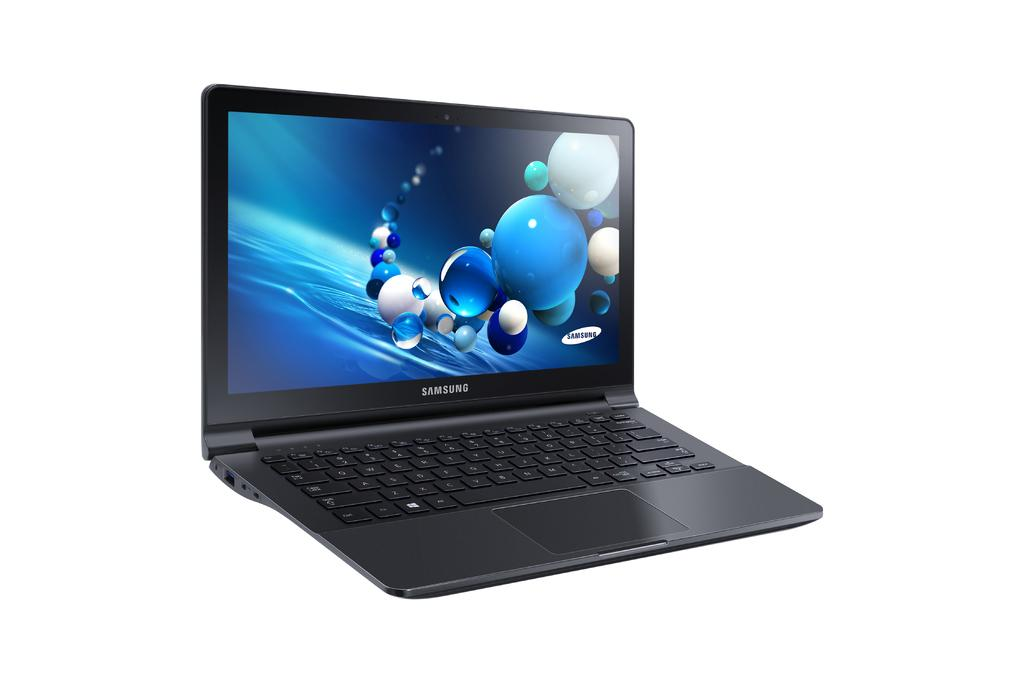<image>
Offer a succinct explanation of the picture presented. An adverisement showing only a Samsung laptop computer 